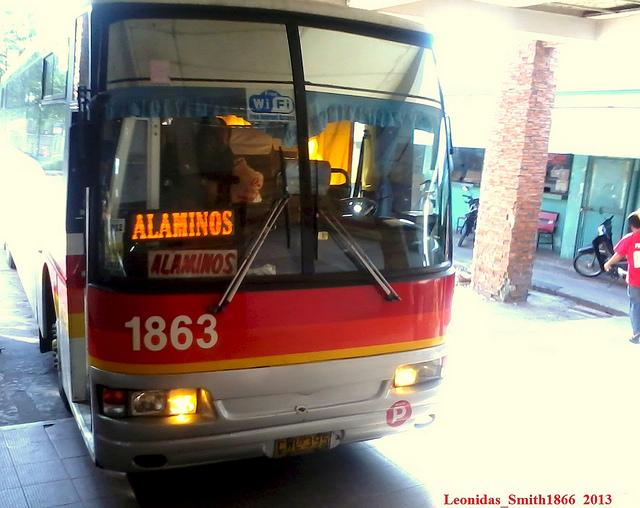What are the metal poles on the window called? wipers 